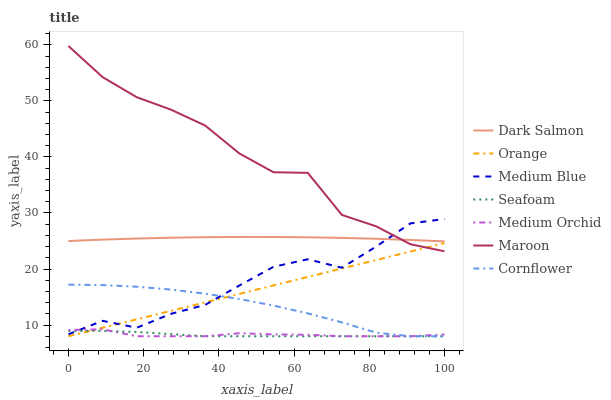Does Seafoam have the minimum area under the curve?
Answer yes or no. Yes. Does Maroon have the maximum area under the curve?
Answer yes or no. Yes. Does Medium Orchid have the minimum area under the curve?
Answer yes or no. No. Does Medium Orchid have the maximum area under the curve?
Answer yes or no. No. Is Orange the smoothest?
Answer yes or no. Yes. Is Maroon the roughest?
Answer yes or no. Yes. Is Medium Orchid the smoothest?
Answer yes or no. No. Is Medium Orchid the roughest?
Answer yes or no. No. Does Cornflower have the lowest value?
Answer yes or no. Yes. Does Medium Blue have the lowest value?
Answer yes or no. No. Does Maroon have the highest value?
Answer yes or no. Yes. Does Medium Orchid have the highest value?
Answer yes or no. No. Is Orange less than Dark Salmon?
Answer yes or no. Yes. Is Dark Salmon greater than Cornflower?
Answer yes or no. Yes. Does Medium Blue intersect Cornflower?
Answer yes or no. Yes. Is Medium Blue less than Cornflower?
Answer yes or no. No. Is Medium Blue greater than Cornflower?
Answer yes or no. No. Does Orange intersect Dark Salmon?
Answer yes or no. No. 